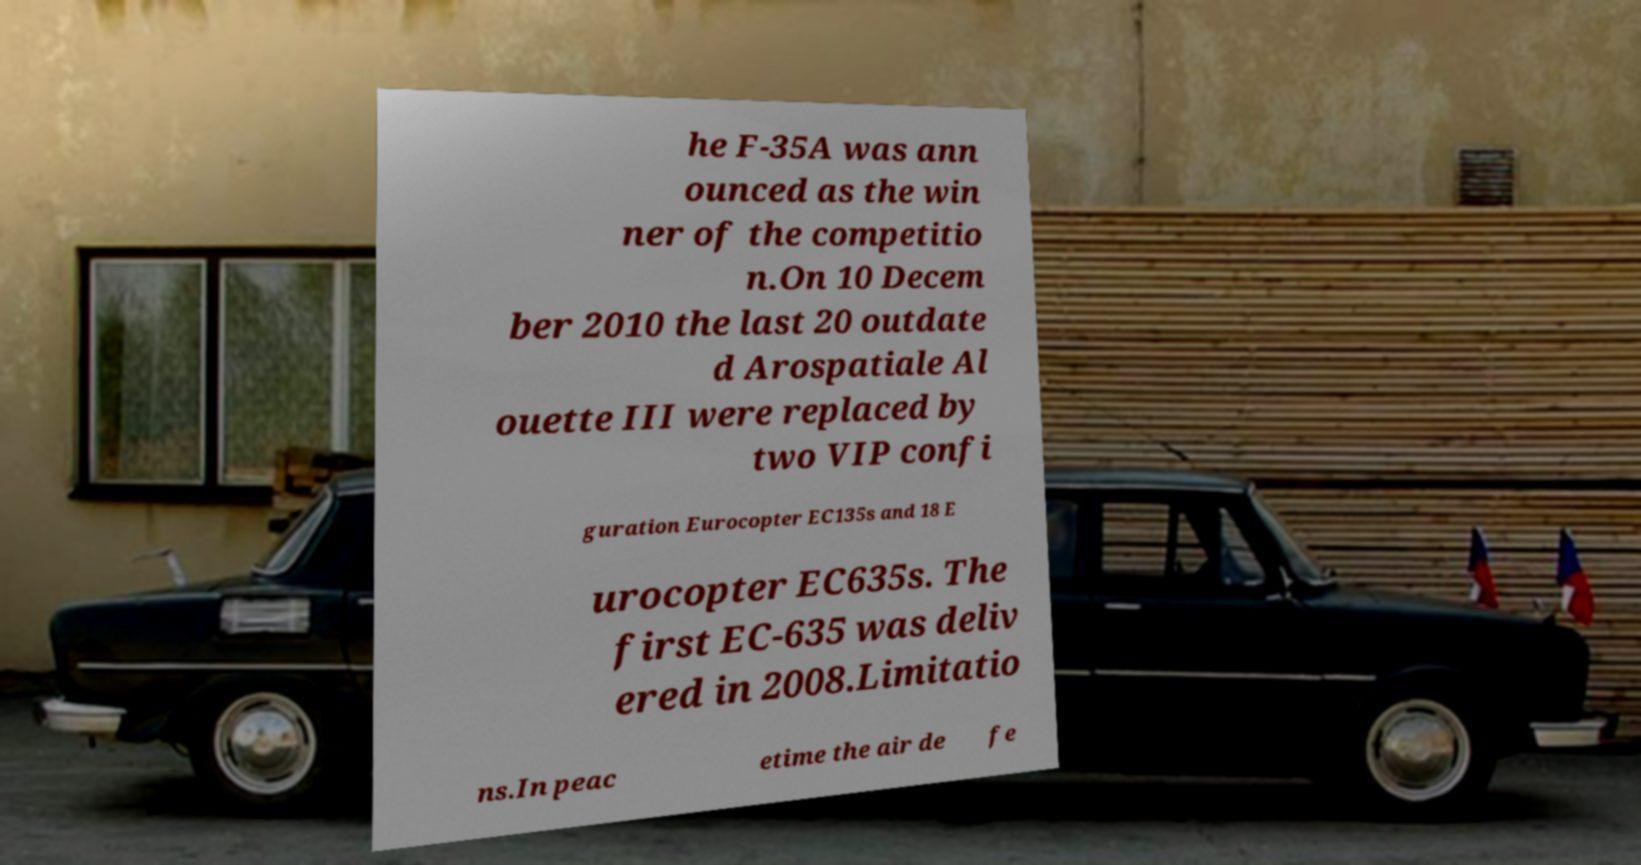What messages or text are displayed in this image? I need them in a readable, typed format. he F-35A was ann ounced as the win ner of the competitio n.On 10 Decem ber 2010 the last 20 outdate d Arospatiale Al ouette III were replaced by two VIP confi guration Eurocopter EC135s and 18 E urocopter EC635s. The first EC-635 was deliv ered in 2008.Limitatio ns.In peac etime the air de fe 